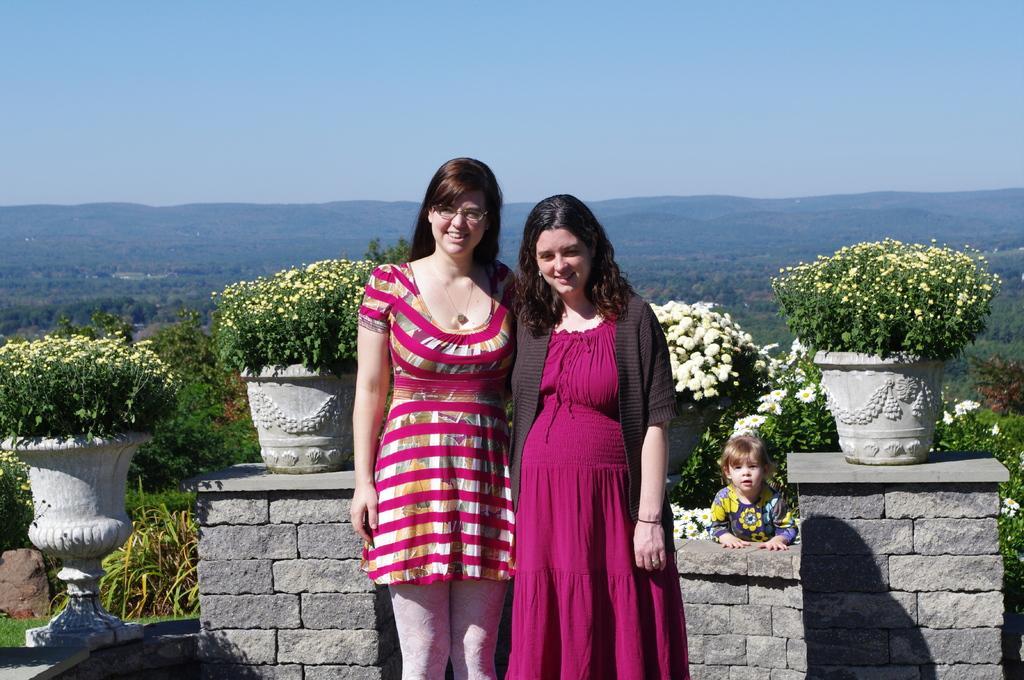Describe this image in one or two sentences. In this image there are two persons standing in the middle of this image. There are some flower pots with some flowers and trees are in the background. There is a sky on the top of this image. There is one kid standing on the right side of this image. 